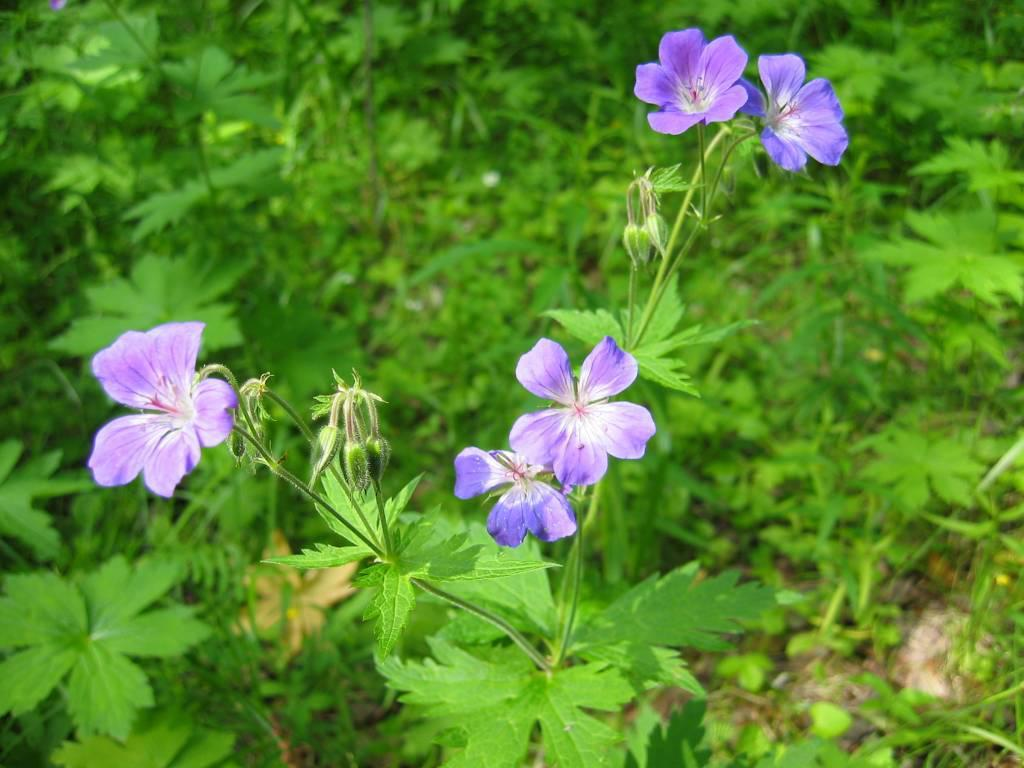What is located in the middle of the image? There are plants, flowers, and leaves in the middle of the image. What type of vegetation is present in the middle of the image? The middle of the image contains plants and flowers. What can be seen in the background of the image? There are plants and grass in the background of the image. What type of beef is being served on a plate in the image? There is no beef or plate present in the image; it features plants, flowers, and leaves. What point is being made by the plants in the image? The plants in the image are not making any point; they are simply depicted as part of the scene. 